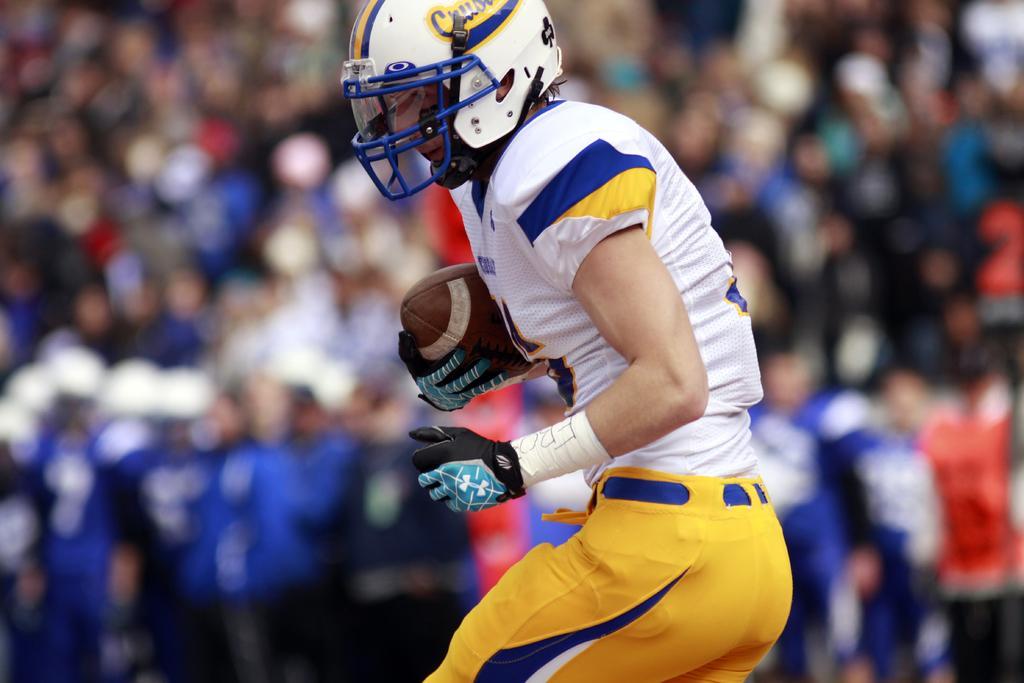Could you give a brief overview of what you see in this image? In this image we can see a person wearing sports uniform and helmet is holding a rugby ball and blurry background. 